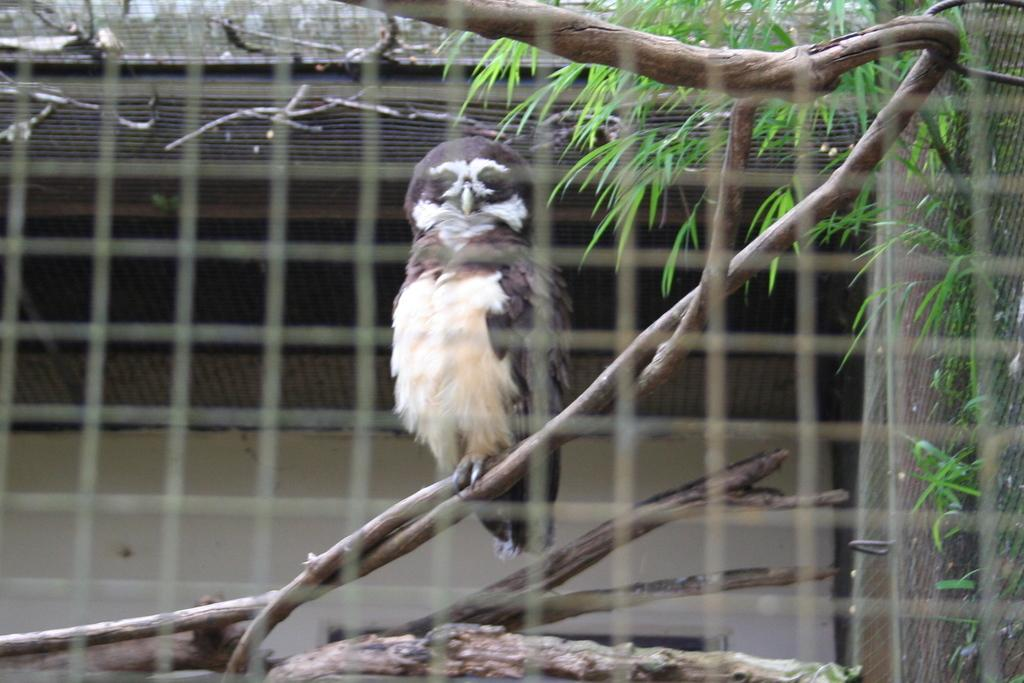What type of animal is in the image? There is an owl in the image. Where is the owl located? The owl is on the branch of a plant. What can be seen in the image that resembles a net or grid? There is a mesh in the image. What type of material is used for some objects in the image? There are wooden objects in the image. What can be seen in the distance in the image? There is a building in the background of the image. What type of example is being set by the land on the side in the image? There is no land or side mentioned in the image; it features an owl on a plant branch, a mesh, wooden objects, and a building in the background. 